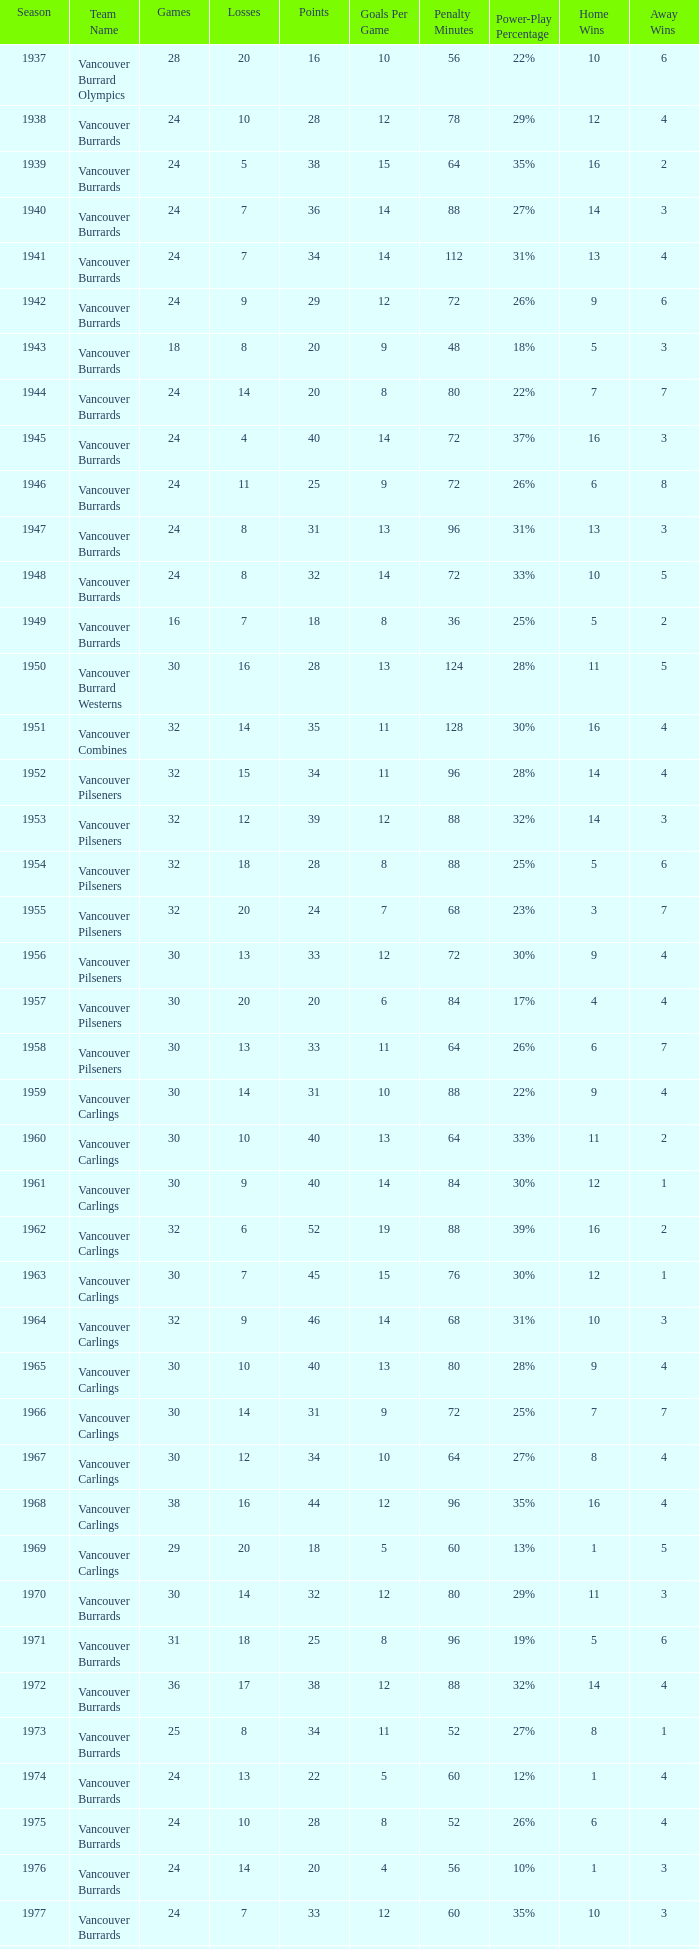What's the total number of games with more than 20 points for the 1976 season? 0.0. 